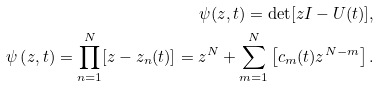<formula> <loc_0><loc_0><loc_500><loc_500>\psi ( z , t ) = \det [ z I - U ( t ) ] , \\ \psi \left ( z , t \right ) = \prod _ { n = 1 } ^ { N } [ z - z _ { n } ( t ) ] = z ^ { N } + \sum _ { m = 1 } ^ { N } \left [ c _ { m } ( t ) z ^ { N - m } \right ] .</formula> 